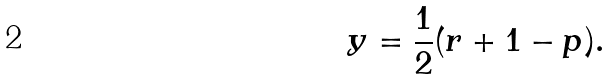<formula> <loc_0><loc_0><loc_500><loc_500>y = \frac { 1 } { 2 } ( r + 1 - p ) .</formula> 